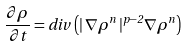<formula> <loc_0><loc_0><loc_500><loc_500>\frac { \partial \rho } { \partial t } = d i v \, \left ( | \, \nabla \rho ^ { n } \, | ^ { p - 2 } \nabla \rho ^ { n } \right )</formula> 